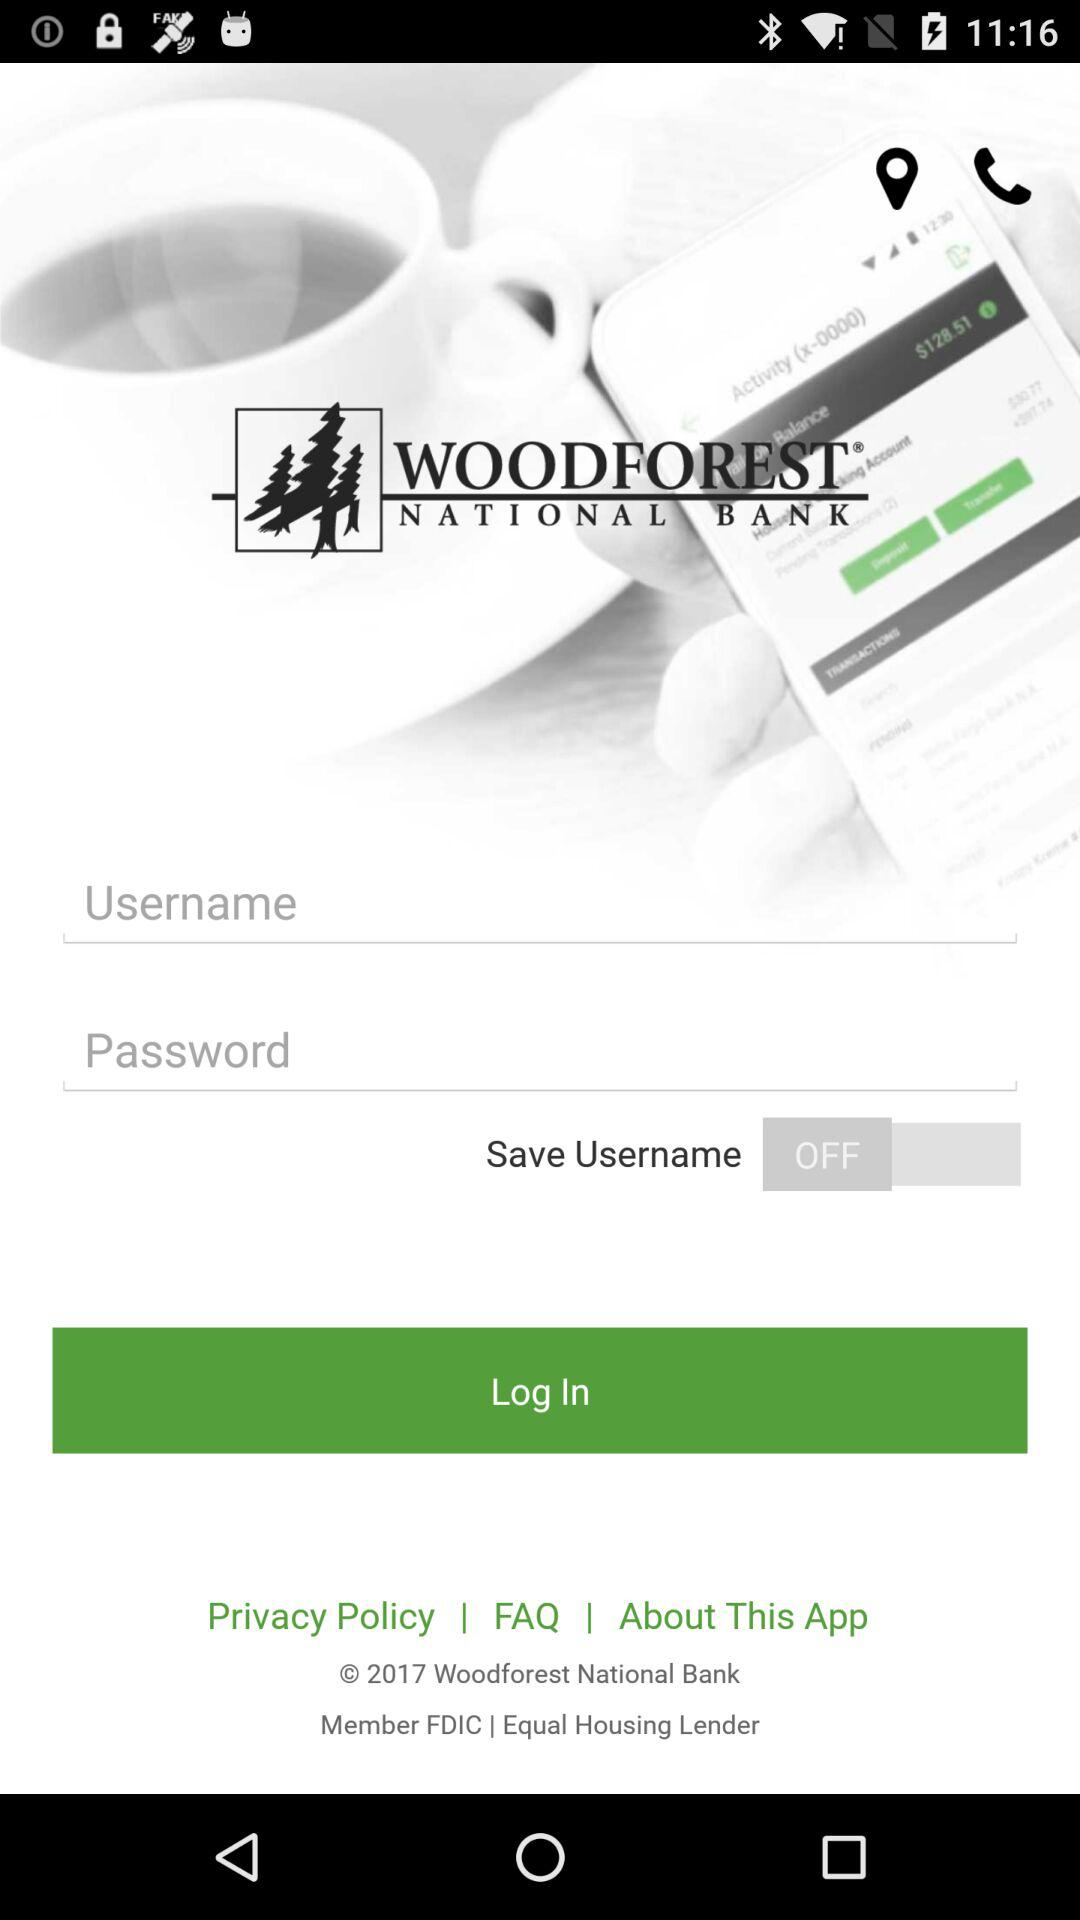What is the name of the application? The name of the application is "WOODFOREST". 